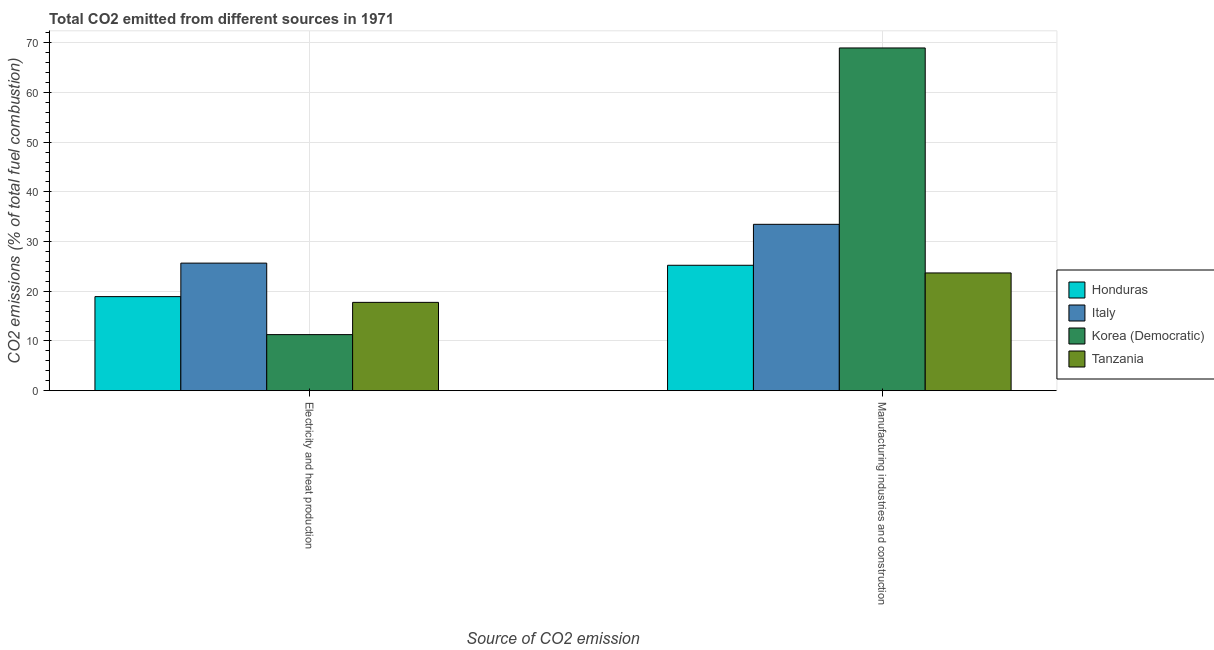How many different coloured bars are there?
Provide a succinct answer. 4. How many groups of bars are there?
Your response must be concise. 2. How many bars are there on the 1st tick from the left?
Make the answer very short. 4. What is the label of the 2nd group of bars from the left?
Your response must be concise. Manufacturing industries and construction. What is the co2 emissions due to manufacturing industries in Korea (Democratic)?
Make the answer very short. 68.95. Across all countries, what is the maximum co2 emissions due to electricity and heat production?
Keep it short and to the point. 25.66. Across all countries, what is the minimum co2 emissions due to manufacturing industries?
Offer a terse response. 23.68. In which country was the co2 emissions due to electricity and heat production maximum?
Your answer should be very brief. Italy. In which country was the co2 emissions due to electricity and heat production minimum?
Your response must be concise. Korea (Democratic). What is the total co2 emissions due to manufacturing industries in the graph?
Keep it short and to the point. 151.33. What is the difference between the co2 emissions due to electricity and heat production in Tanzania and that in Honduras?
Keep it short and to the point. -1.16. What is the difference between the co2 emissions due to electricity and heat production in Honduras and the co2 emissions due to manufacturing industries in Korea (Democratic)?
Your answer should be compact. -50.03. What is the average co2 emissions due to electricity and heat production per country?
Your answer should be very brief. 18.4. What is the difference between the co2 emissions due to manufacturing industries and co2 emissions due to electricity and heat production in Tanzania?
Your answer should be compact. 5.92. What is the ratio of the co2 emissions due to manufacturing industries in Korea (Democratic) to that in Honduras?
Give a very brief answer. 2.73. Is the co2 emissions due to electricity and heat production in Honduras less than that in Tanzania?
Provide a short and direct response. No. What does the 1st bar from the left in Manufacturing industries and construction represents?
Your answer should be compact. Honduras. What does the 2nd bar from the right in Electricity and heat production represents?
Provide a succinct answer. Korea (Democratic). Are all the bars in the graph horizontal?
Provide a short and direct response. No. What is the difference between two consecutive major ticks on the Y-axis?
Your answer should be very brief. 10. How many legend labels are there?
Your answer should be compact. 4. What is the title of the graph?
Offer a very short reply. Total CO2 emitted from different sources in 1971. What is the label or title of the X-axis?
Your response must be concise. Source of CO2 emission. What is the label or title of the Y-axis?
Offer a terse response. CO2 emissions (% of total fuel combustion). What is the CO2 emissions (% of total fuel combustion) of Honduras in Electricity and heat production?
Keep it short and to the point. 18.92. What is the CO2 emissions (% of total fuel combustion) in Italy in Electricity and heat production?
Your answer should be compact. 25.66. What is the CO2 emissions (% of total fuel combustion) in Korea (Democratic) in Electricity and heat production?
Your answer should be compact. 11.27. What is the CO2 emissions (% of total fuel combustion) in Tanzania in Electricity and heat production?
Your answer should be compact. 17.76. What is the CO2 emissions (% of total fuel combustion) of Honduras in Manufacturing industries and construction?
Keep it short and to the point. 25.23. What is the CO2 emissions (% of total fuel combustion) of Italy in Manufacturing industries and construction?
Give a very brief answer. 33.47. What is the CO2 emissions (% of total fuel combustion) in Korea (Democratic) in Manufacturing industries and construction?
Make the answer very short. 68.95. What is the CO2 emissions (% of total fuel combustion) in Tanzania in Manufacturing industries and construction?
Your answer should be very brief. 23.68. Across all Source of CO2 emission, what is the maximum CO2 emissions (% of total fuel combustion) of Honduras?
Ensure brevity in your answer.  25.23. Across all Source of CO2 emission, what is the maximum CO2 emissions (% of total fuel combustion) of Italy?
Your response must be concise. 33.47. Across all Source of CO2 emission, what is the maximum CO2 emissions (% of total fuel combustion) of Korea (Democratic)?
Provide a succinct answer. 68.95. Across all Source of CO2 emission, what is the maximum CO2 emissions (% of total fuel combustion) in Tanzania?
Keep it short and to the point. 23.68. Across all Source of CO2 emission, what is the minimum CO2 emissions (% of total fuel combustion) of Honduras?
Your response must be concise. 18.92. Across all Source of CO2 emission, what is the minimum CO2 emissions (% of total fuel combustion) of Italy?
Ensure brevity in your answer.  25.66. Across all Source of CO2 emission, what is the minimum CO2 emissions (% of total fuel combustion) of Korea (Democratic)?
Your response must be concise. 11.27. Across all Source of CO2 emission, what is the minimum CO2 emissions (% of total fuel combustion) in Tanzania?
Provide a succinct answer. 17.76. What is the total CO2 emissions (% of total fuel combustion) in Honduras in the graph?
Your answer should be compact. 44.14. What is the total CO2 emissions (% of total fuel combustion) in Italy in the graph?
Your response must be concise. 59.13. What is the total CO2 emissions (% of total fuel combustion) in Korea (Democratic) in the graph?
Your response must be concise. 80.23. What is the total CO2 emissions (% of total fuel combustion) of Tanzania in the graph?
Ensure brevity in your answer.  41.45. What is the difference between the CO2 emissions (% of total fuel combustion) of Honduras in Electricity and heat production and that in Manufacturing industries and construction?
Your response must be concise. -6.31. What is the difference between the CO2 emissions (% of total fuel combustion) in Italy in Electricity and heat production and that in Manufacturing industries and construction?
Provide a succinct answer. -7.81. What is the difference between the CO2 emissions (% of total fuel combustion) in Korea (Democratic) in Electricity and heat production and that in Manufacturing industries and construction?
Your answer should be compact. -57.68. What is the difference between the CO2 emissions (% of total fuel combustion) of Tanzania in Electricity and heat production and that in Manufacturing industries and construction?
Offer a terse response. -5.92. What is the difference between the CO2 emissions (% of total fuel combustion) in Honduras in Electricity and heat production and the CO2 emissions (% of total fuel combustion) in Italy in Manufacturing industries and construction?
Make the answer very short. -14.55. What is the difference between the CO2 emissions (% of total fuel combustion) of Honduras in Electricity and heat production and the CO2 emissions (% of total fuel combustion) of Korea (Democratic) in Manufacturing industries and construction?
Your answer should be very brief. -50.03. What is the difference between the CO2 emissions (% of total fuel combustion) in Honduras in Electricity and heat production and the CO2 emissions (% of total fuel combustion) in Tanzania in Manufacturing industries and construction?
Your response must be concise. -4.77. What is the difference between the CO2 emissions (% of total fuel combustion) in Italy in Electricity and heat production and the CO2 emissions (% of total fuel combustion) in Korea (Democratic) in Manufacturing industries and construction?
Provide a succinct answer. -43.29. What is the difference between the CO2 emissions (% of total fuel combustion) of Italy in Electricity and heat production and the CO2 emissions (% of total fuel combustion) of Tanzania in Manufacturing industries and construction?
Give a very brief answer. 1.98. What is the difference between the CO2 emissions (% of total fuel combustion) of Korea (Democratic) in Electricity and heat production and the CO2 emissions (% of total fuel combustion) of Tanzania in Manufacturing industries and construction?
Provide a short and direct response. -12.41. What is the average CO2 emissions (% of total fuel combustion) of Honduras per Source of CO2 emission?
Ensure brevity in your answer.  22.07. What is the average CO2 emissions (% of total fuel combustion) in Italy per Source of CO2 emission?
Provide a succinct answer. 29.56. What is the average CO2 emissions (% of total fuel combustion) of Korea (Democratic) per Source of CO2 emission?
Make the answer very short. 40.11. What is the average CO2 emissions (% of total fuel combustion) of Tanzania per Source of CO2 emission?
Your response must be concise. 20.72. What is the difference between the CO2 emissions (% of total fuel combustion) of Honduras and CO2 emissions (% of total fuel combustion) of Italy in Electricity and heat production?
Ensure brevity in your answer.  -6.74. What is the difference between the CO2 emissions (% of total fuel combustion) of Honduras and CO2 emissions (% of total fuel combustion) of Korea (Democratic) in Electricity and heat production?
Provide a succinct answer. 7.65. What is the difference between the CO2 emissions (% of total fuel combustion) of Honduras and CO2 emissions (% of total fuel combustion) of Tanzania in Electricity and heat production?
Give a very brief answer. 1.16. What is the difference between the CO2 emissions (% of total fuel combustion) in Italy and CO2 emissions (% of total fuel combustion) in Korea (Democratic) in Electricity and heat production?
Your response must be concise. 14.39. What is the difference between the CO2 emissions (% of total fuel combustion) in Italy and CO2 emissions (% of total fuel combustion) in Tanzania in Electricity and heat production?
Provide a succinct answer. 7.9. What is the difference between the CO2 emissions (% of total fuel combustion) of Korea (Democratic) and CO2 emissions (% of total fuel combustion) of Tanzania in Electricity and heat production?
Offer a very short reply. -6.49. What is the difference between the CO2 emissions (% of total fuel combustion) in Honduras and CO2 emissions (% of total fuel combustion) in Italy in Manufacturing industries and construction?
Your answer should be very brief. -8.24. What is the difference between the CO2 emissions (% of total fuel combustion) in Honduras and CO2 emissions (% of total fuel combustion) in Korea (Democratic) in Manufacturing industries and construction?
Make the answer very short. -43.73. What is the difference between the CO2 emissions (% of total fuel combustion) in Honduras and CO2 emissions (% of total fuel combustion) in Tanzania in Manufacturing industries and construction?
Provide a succinct answer. 1.54. What is the difference between the CO2 emissions (% of total fuel combustion) in Italy and CO2 emissions (% of total fuel combustion) in Korea (Democratic) in Manufacturing industries and construction?
Provide a short and direct response. -35.49. What is the difference between the CO2 emissions (% of total fuel combustion) of Italy and CO2 emissions (% of total fuel combustion) of Tanzania in Manufacturing industries and construction?
Provide a succinct answer. 9.78. What is the difference between the CO2 emissions (% of total fuel combustion) of Korea (Democratic) and CO2 emissions (% of total fuel combustion) of Tanzania in Manufacturing industries and construction?
Your answer should be compact. 45.27. What is the ratio of the CO2 emissions (% of total fuel combustion) in Italy in Electricity and heat production to that in Manufacturing industries and construction?
Provide a short and direct response. 0.77. What is the ratio of the CO2 emissions (% of total fuel combustion) in Korea (Democratic) in Electricity and heat production to that in Manufacturing industries and construction?
Your answer should be very brief. 0.16. What is the difference between the highest and the second highest CO2 emissions (% of total fuel combustion) in Honduras?
Your answer should be compact. 6.31. What is the difference between the highest and the second highest CO2 emissions (% of total fuel combustion) of Italy?
Provide a short and direct response. 7.81. What is the difference between the highest and the second highest CO2 emissions (% of total fuel combustion) in Korea (Democratic)?
Give a very brief answer. 57.68. What is the difference between the highest and the second highest CO2 emissions (% of total fuel combustion) of Tanzania?
Your response must be concise. 5.92. What is the difference between the highest and the lowest CO2 emissions (% of total fuel combustion) of Honduras?
Give a very brief answer. 6.31. What is the difference between the highest and the lowest CO2 emissions (% of total fuel combustion) of Italy?
Provide a short and direct response. 7.81. What is the difference between the highest and the lowest CO2 emissions (% of total fuel combustion) in Korea (Democratic)?
Make the answer very short. 57.68. What is the difference between the highest and the lowest CO2 emissions (% of total fuel combustion) of Tanzania?
Give a very brief answer. 5.92. 